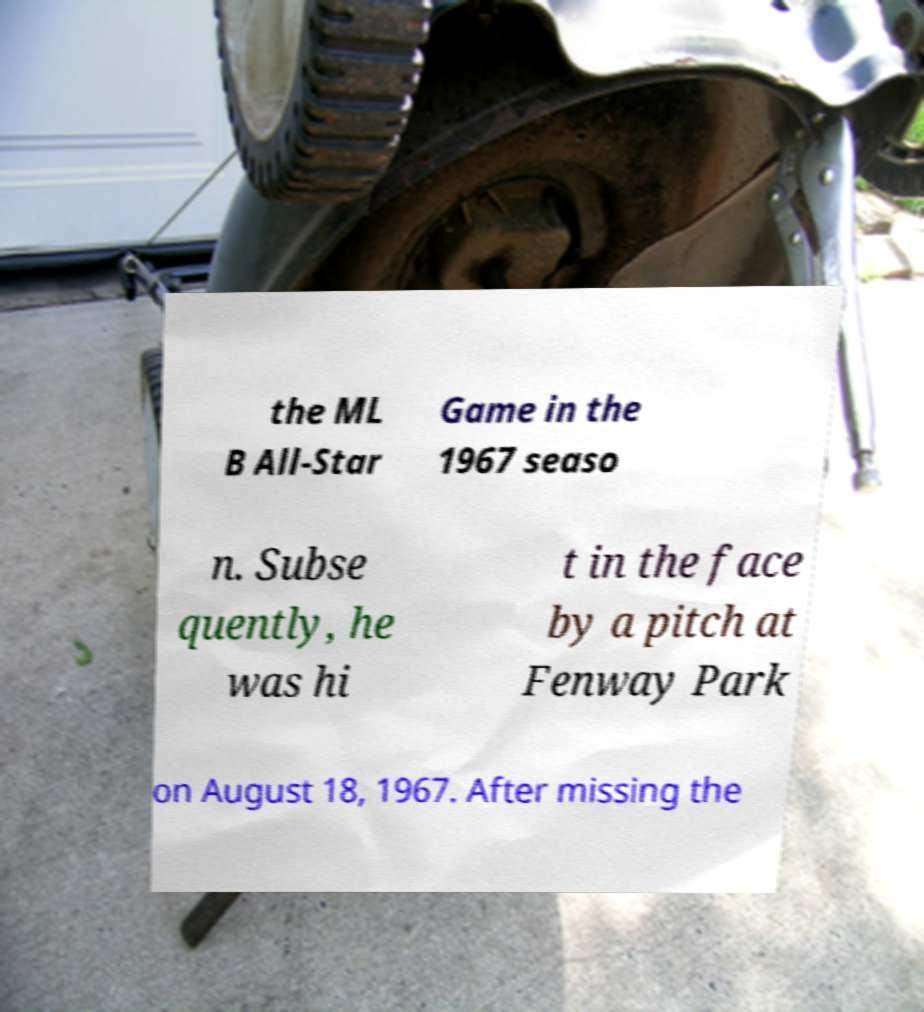Could you extract and type out the text from this image? the ML B All-Star Game in the 1967 seaso n. Subse quently, he was hi t in the face by a pitch at Fenway Park on August 18, 1967. After missing the 